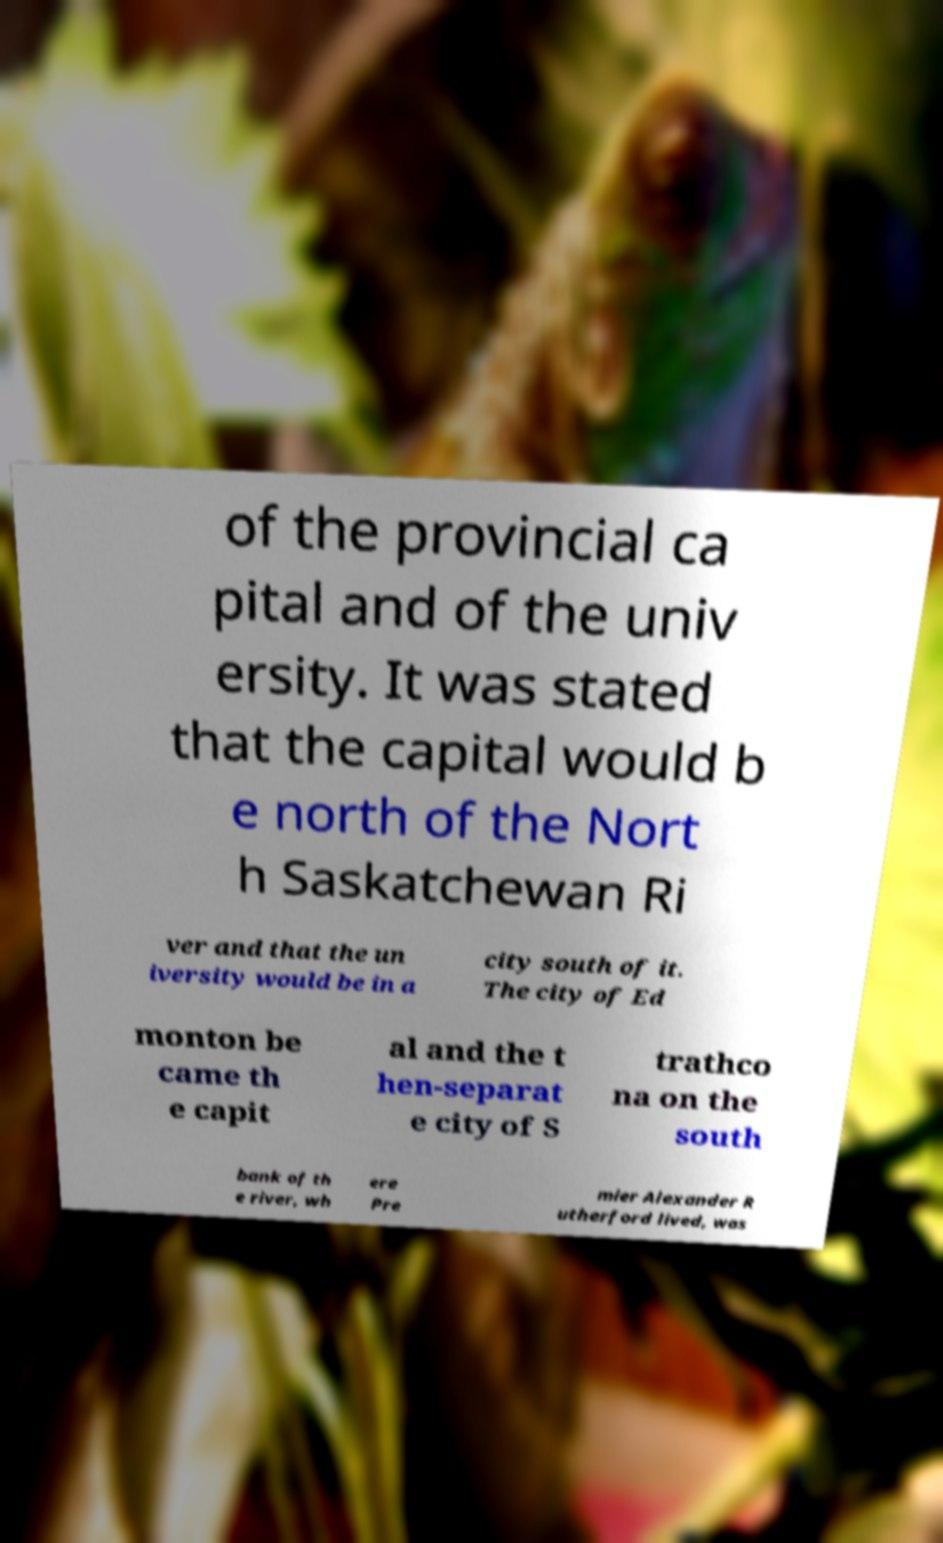Could you assist in decoding the text presented in this image and type it out clearly? of the provincial ca pital and of the univ ersity. It was stated that the capital would b e north of the Nort h Saskatchewan Ri ver and that the un iversity would be in a city south of it. The city of Ed monton be came th e capit al and the t hen-separat e city of S trathco na on the south bank of th e river, wh ere Pre mier Alexander R utherford lived, was 